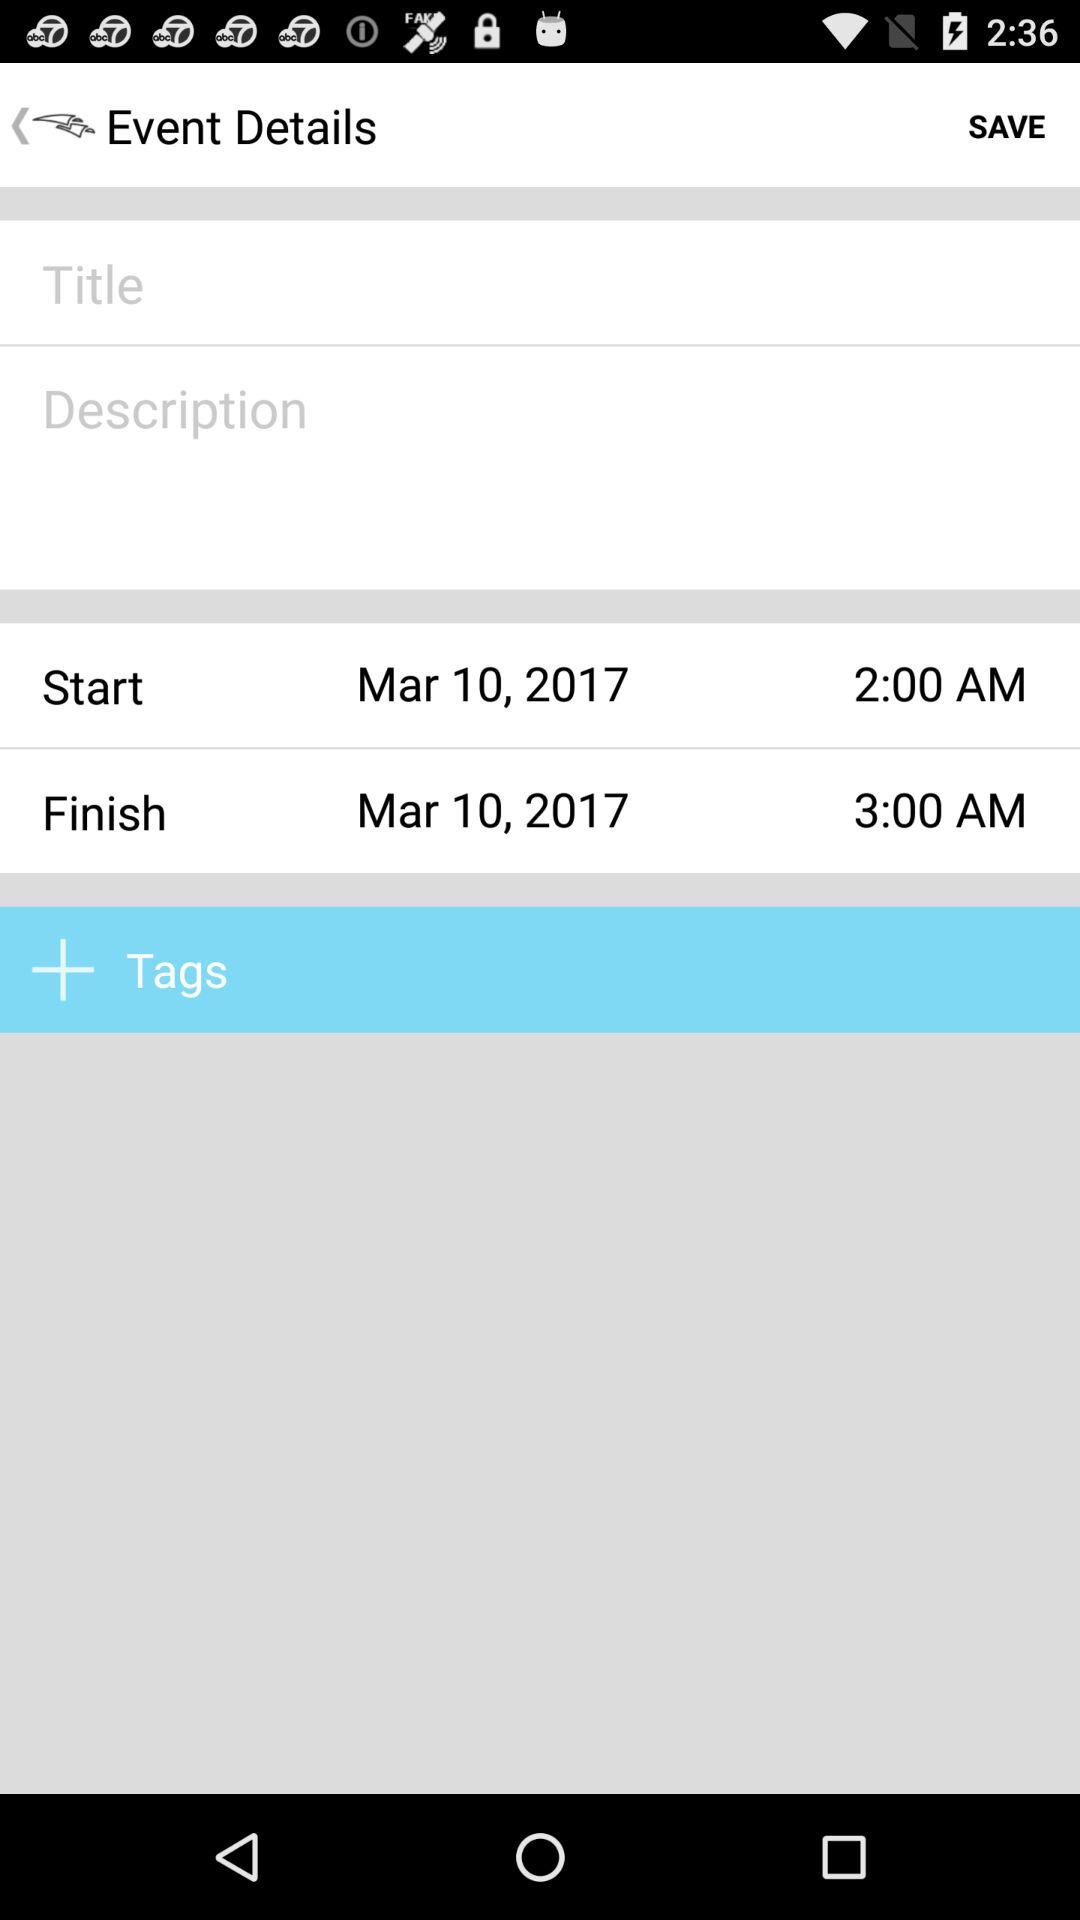What is the start date? The start date is March 10, 2017. 